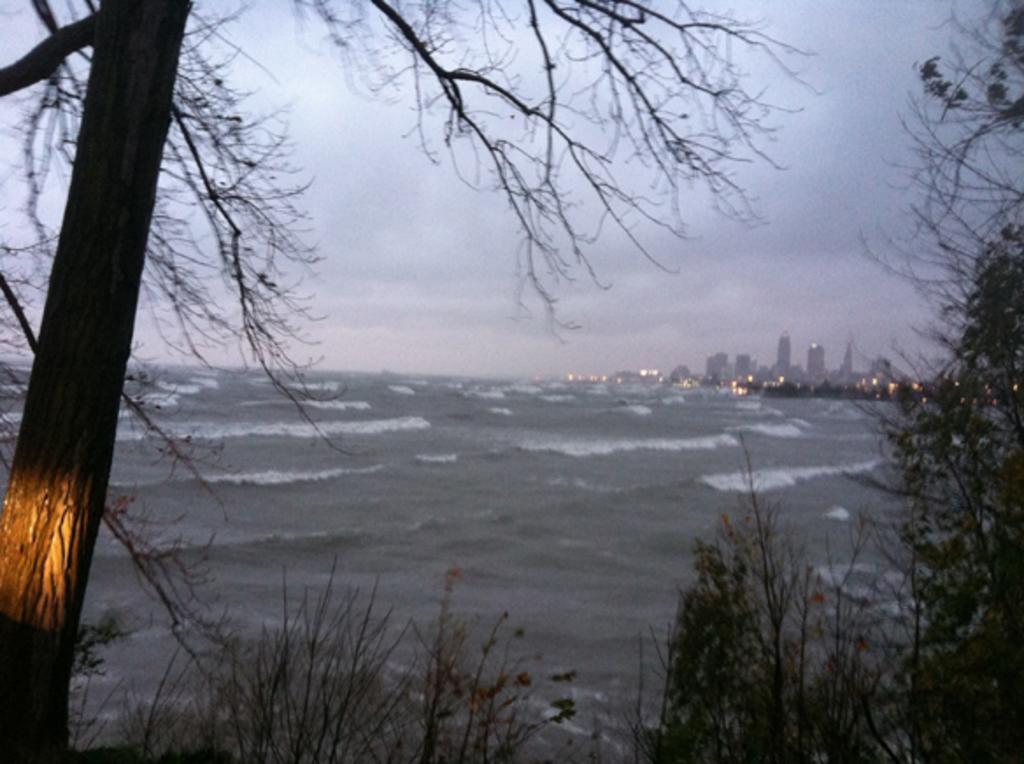Could you give a brief overview of what you see in this image? In this image I can see the trees. I can see the water waves. In the background, I can see the buildings and clouds in the sky. 